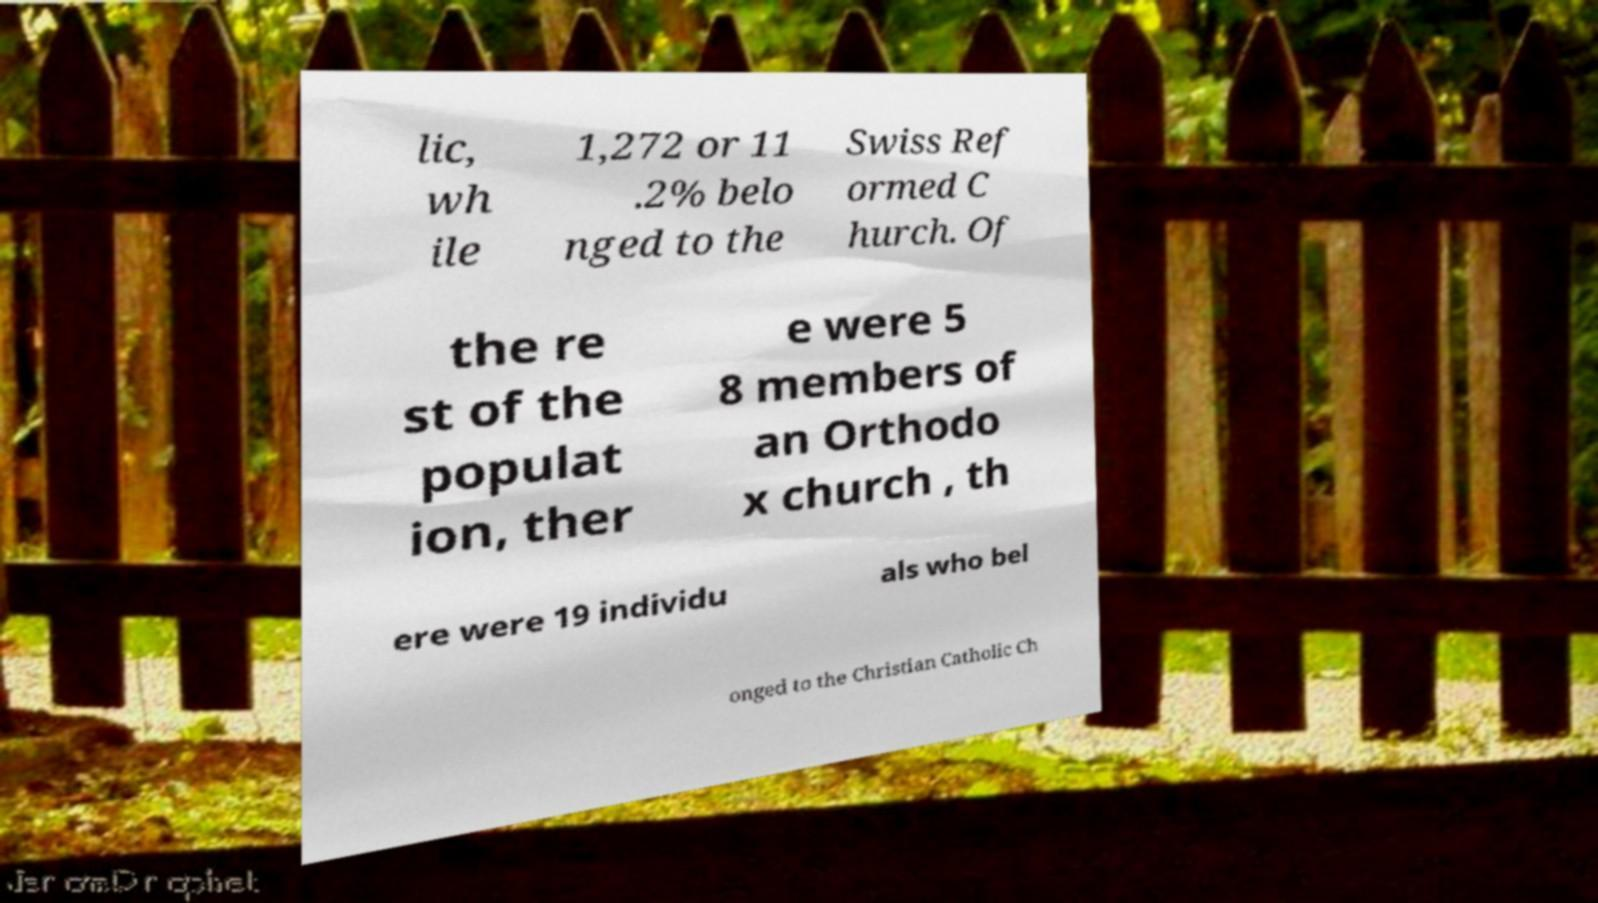Please read and relay the text visible in this image. What does it say? lic, wh ile 1,272 or 11 .2% belo nged to the Swiss Ref ormed C hurch. Of the re st of the populat ion, ther e were 5 8 members of an Orthodo x church , th ere were 19 individu als who bel onged to the Christian Catholic Ch 